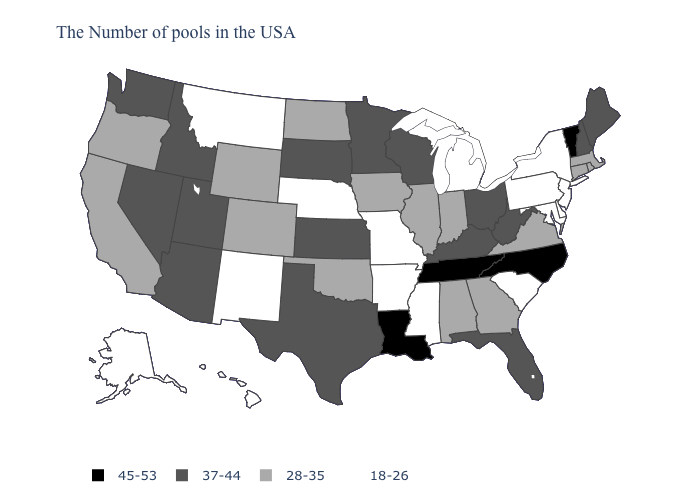Name the states that have a value in the range 37-44?
Be succinct. Maine, New Hampshire, West Virginia, Ohio, Florida, Kentucky, Wisconsin, Minnesota, Kansas, Texas, South Dakota, Utah, Arizona, Idaho, Nevada, Washington. Does the map have missing data?
Be succinct. No. Name the states that have a value in the range 28-35?
Short answer required. Massachusetts, Rhode Island, Connecticut, Virginia, Georgia, Indiana, Alabama, Illinois, Iowa, Oklahoma, North Dakota, Wyoming, Colorado, California, Oregon. Among the states that border New Hampshire , does Massachusetts have the lowest value?
Quick response, please. Yes. Does New Jersey have the lowest value in the USA?
Concise answer only. Yes. Name the states that have a value in the range 45-53?
Give a very brief answer. Vermont, North Carolina, Tennessee, Louisiana. Name the states that have a value in the range 28-35?
Be succinct. Massachusetts, Rhode Island, Connecticut, Virginia, Georgia, Indiana, Alabama, Illinois, Iowa, Oklahoma, North Dakota, Wyoming, Colorado, California, Oregon. What is the value of Pennsylvania?
Keep it brief. 18-26. Is the legend a continuous bar?
Short answer required. No. What is the lowest value in states that border Rhode Island?
Be succinct. 28-35. What is the value of Florida?
Be succinct. 37-44. Name the states that have a value in the range 18-26?
Concise answer only. New York, New Jersey, Delaware, Maryland, Pennsylvania, South Carolina, Michigan, Mississippi, Missouri, Arkansas, Nebraska, New Mexico, Montana, Alaska, Hawaii. Which states have the lowest value in the USA?
Keep it brief. New York, New Jersey, Delaware, Maryland, Pennsylvania, South Carolina, Michigan, Mississippi, Missouri, Arkansas, Nebraska, New Mexico, Montana, Alaska, Hawaii. Does the first symbol in the legend represent the smallest category?
Give a very brief answer. No. What is the value of Florida?
Short answer required. 37-44. 